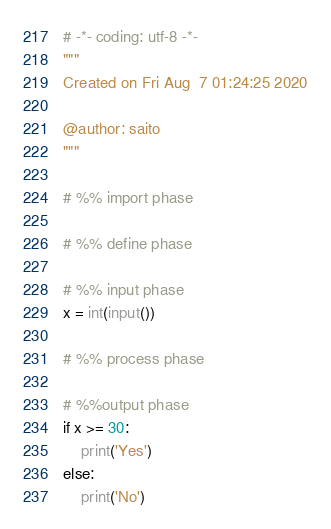<code> <loc_0><loc_0><loc_500><loc_500><_Python_># -*- coding: utf-8 -*-
"""
Created on Fri Aug  7 01:24:25 2020

@author: saito
"""

# %% import phase

# %% define phase

# %% input phase
x = int(input())

# %% process phase

# %%output phase
if x >= 30:
    print('Yes')
else:
    print('No')</code> 